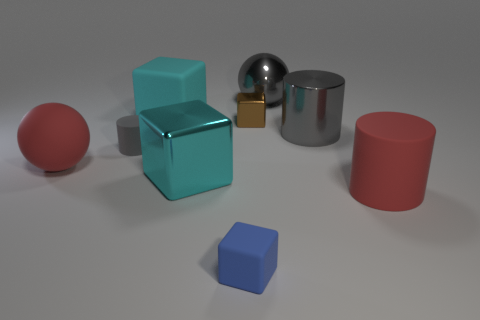Subtract all brown blocks. How many blocks are left? 3 Add 1 small brown cubes. How many objects exist? 10 Subtract 1 cylinders. How many cylinders are left? 2 Subtract all purple cylinders. How many cyan cubes are left? 2 Subtract all cylinders. How many objects are left? 6 Subtract all red balls. How many balls are left? 1 Subtract all yellow balls. Subtract all blue cubes. How many balls are left? 2 Subtract all large green matte cylinders. Subtract all large cyan shiny things. How many objects are left? 8 Add 7 cyan matte blocks. How many cyan matte blocks are left? 8 Add 8 big shiny cubes. How many big shiny cubes exist? 9 